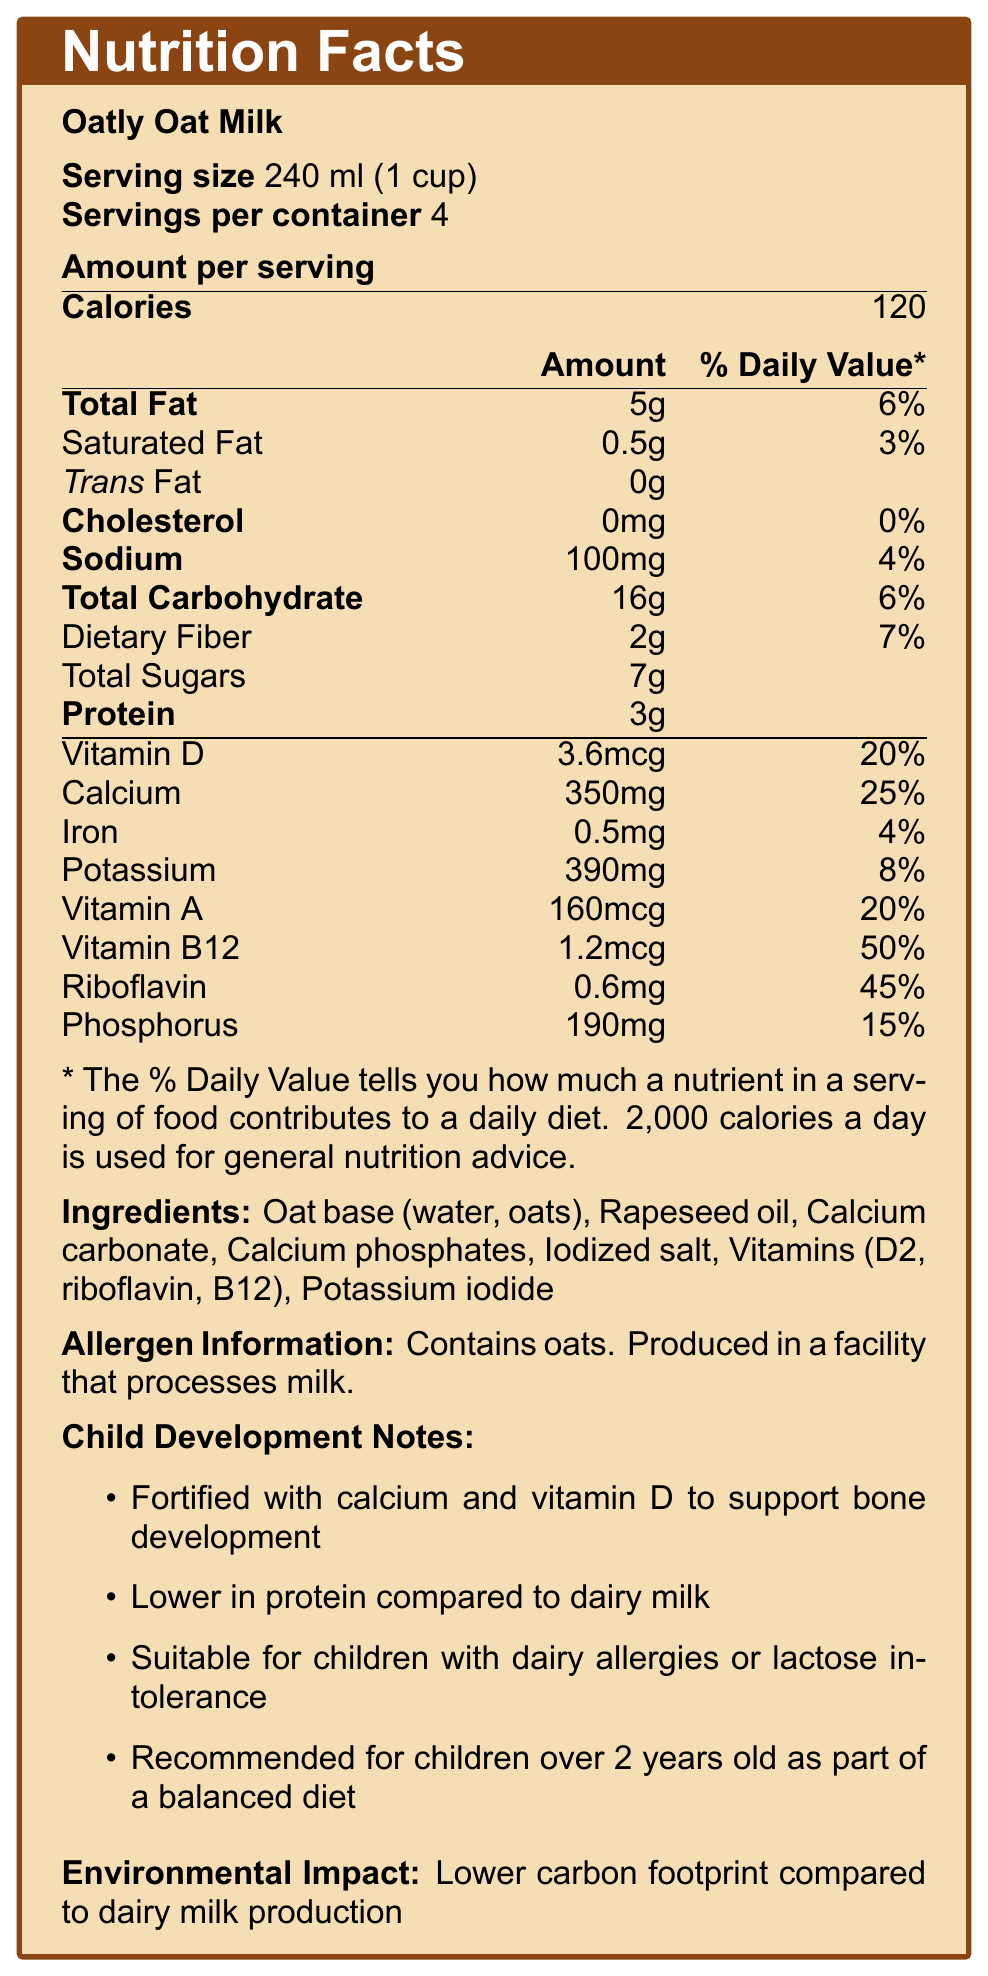what is the serving size for Oatly Oat Milk? Serving size is directly stated in the document as 240 ml (1 cup).
Answer: 240 ml (1 cup) how many calories are in one serving? The document lists the amount of calories per serving as 120.
Answer: 120 how much saturated fat is in one serving? The amount of saturated fat per serving is specified as 0.5g in the document.
Answer: 0.5g what is the daily value percentage for calcium in one serving? The daily value percentage for calcium is indicated as 25% in the document.
Answer: 25% what is the vitamin B12 content in one serving? The vitamin B12 content per serving is listed as 1.2mcg.
Answer: 1.2mcg how much protein does Oatly Oat Milk contain compared to dairy milk? A. More B. Less C. The same The document states that Oatly Oat Milk has lower protein content compared to cow's milk (3g vs 8g per cup).
Answer: B what is the main ingredient of Oatly Oat Milk? A. Soy B. Oats C. Almonds D. Rice The main ingredient in Oatly Oat Milk is oats as specified in the ingredients list.
Answer: B is Oatly Oat Milk suitable for lactose-intolerant children? The document mentions that it is naturally lactose-free, making it suitable for lactose-intolerant children.
Answer: Yes does Oatly Oat Milk contain cholesterol? The label shows that Oatly Oat Milk has 0mg of cholesterol.
Answer: No summarize the document The document provides a comprehensive overview of the nutritional information for Oatly Oat Milk, including ingredients, allergen information, and its environmental benefits compared to dairy milk. Additionally, it outlines the suitability for children, particularly those with dairy allergies or lactose intolerance.
Answer: The document is a Nutrition Facts Label for Oatly Oat Milk, detailing its nutritional content per serving, including calories, fat, protein, vitamins, and minerals. It also compares its nutritional value to dairy milk, highlighting some benefits like being suitable for lactose-intolerant children, and environmental impacts. what is the total amount of carbohydrates in one serving? As stated in the document, the total carbohydrate content per serving is 16g.
Answer: 16g how much sodium is in one serving? The sodium content per serving is 100mg, according to the document.
Answer: 100mg is Oatly Oat Milk produced in a dairy-free facility? The document indicates that it is produced in a facility that processes milk.
Answer: No what is the environmental impact of Oatly Oat Milk compared to dairy milk? The document notes that Oatly Oat Milk has a lower carbon footprint compared to dairy milk production.
Answer: Lower carbon footprint can Oatly Oat Milk be given to infants under 2 years old? The document specifies that it is recommended for children over 2 years old.
Answer: No how long does each container of Oatly Oat Milk last if one serving is consumed daily? Each container has 4 servings, so consuming one serving daily would make the container last for 4 days.
Answer: 4 days how much dietary fiber does Oatly Oat Milk provide per serving? The dietary fiber content is listed as 2g per serving.
Answer: 2g how much vitamin A is in a serving of Oatly Oat Milk? The document lists vitamin A content per serving as 160mcg.
Answer: 160mcg does Oatly Oat Milk have any trans fat? The label shows that Oatly Oat Milk contains 0g of trans fat.
Answer: No which of the following nutrients is highest in terms of daily value percentage in Oatly Oat Milk? A. Vitamin D B. Calcium C. Vitamin B12 D. Riboflavin Vitamin B12 has the highest daily value percentage at 50%, as stated in the document.
Answer: C what is the exact fat profile difference between Oatly Oat Milk and whole dairy milk? The document states that Oatly Oat Milk is lower in saturated fat than whole milk but does not provide the specific fat profiles of both.
Answer: Not enough information 